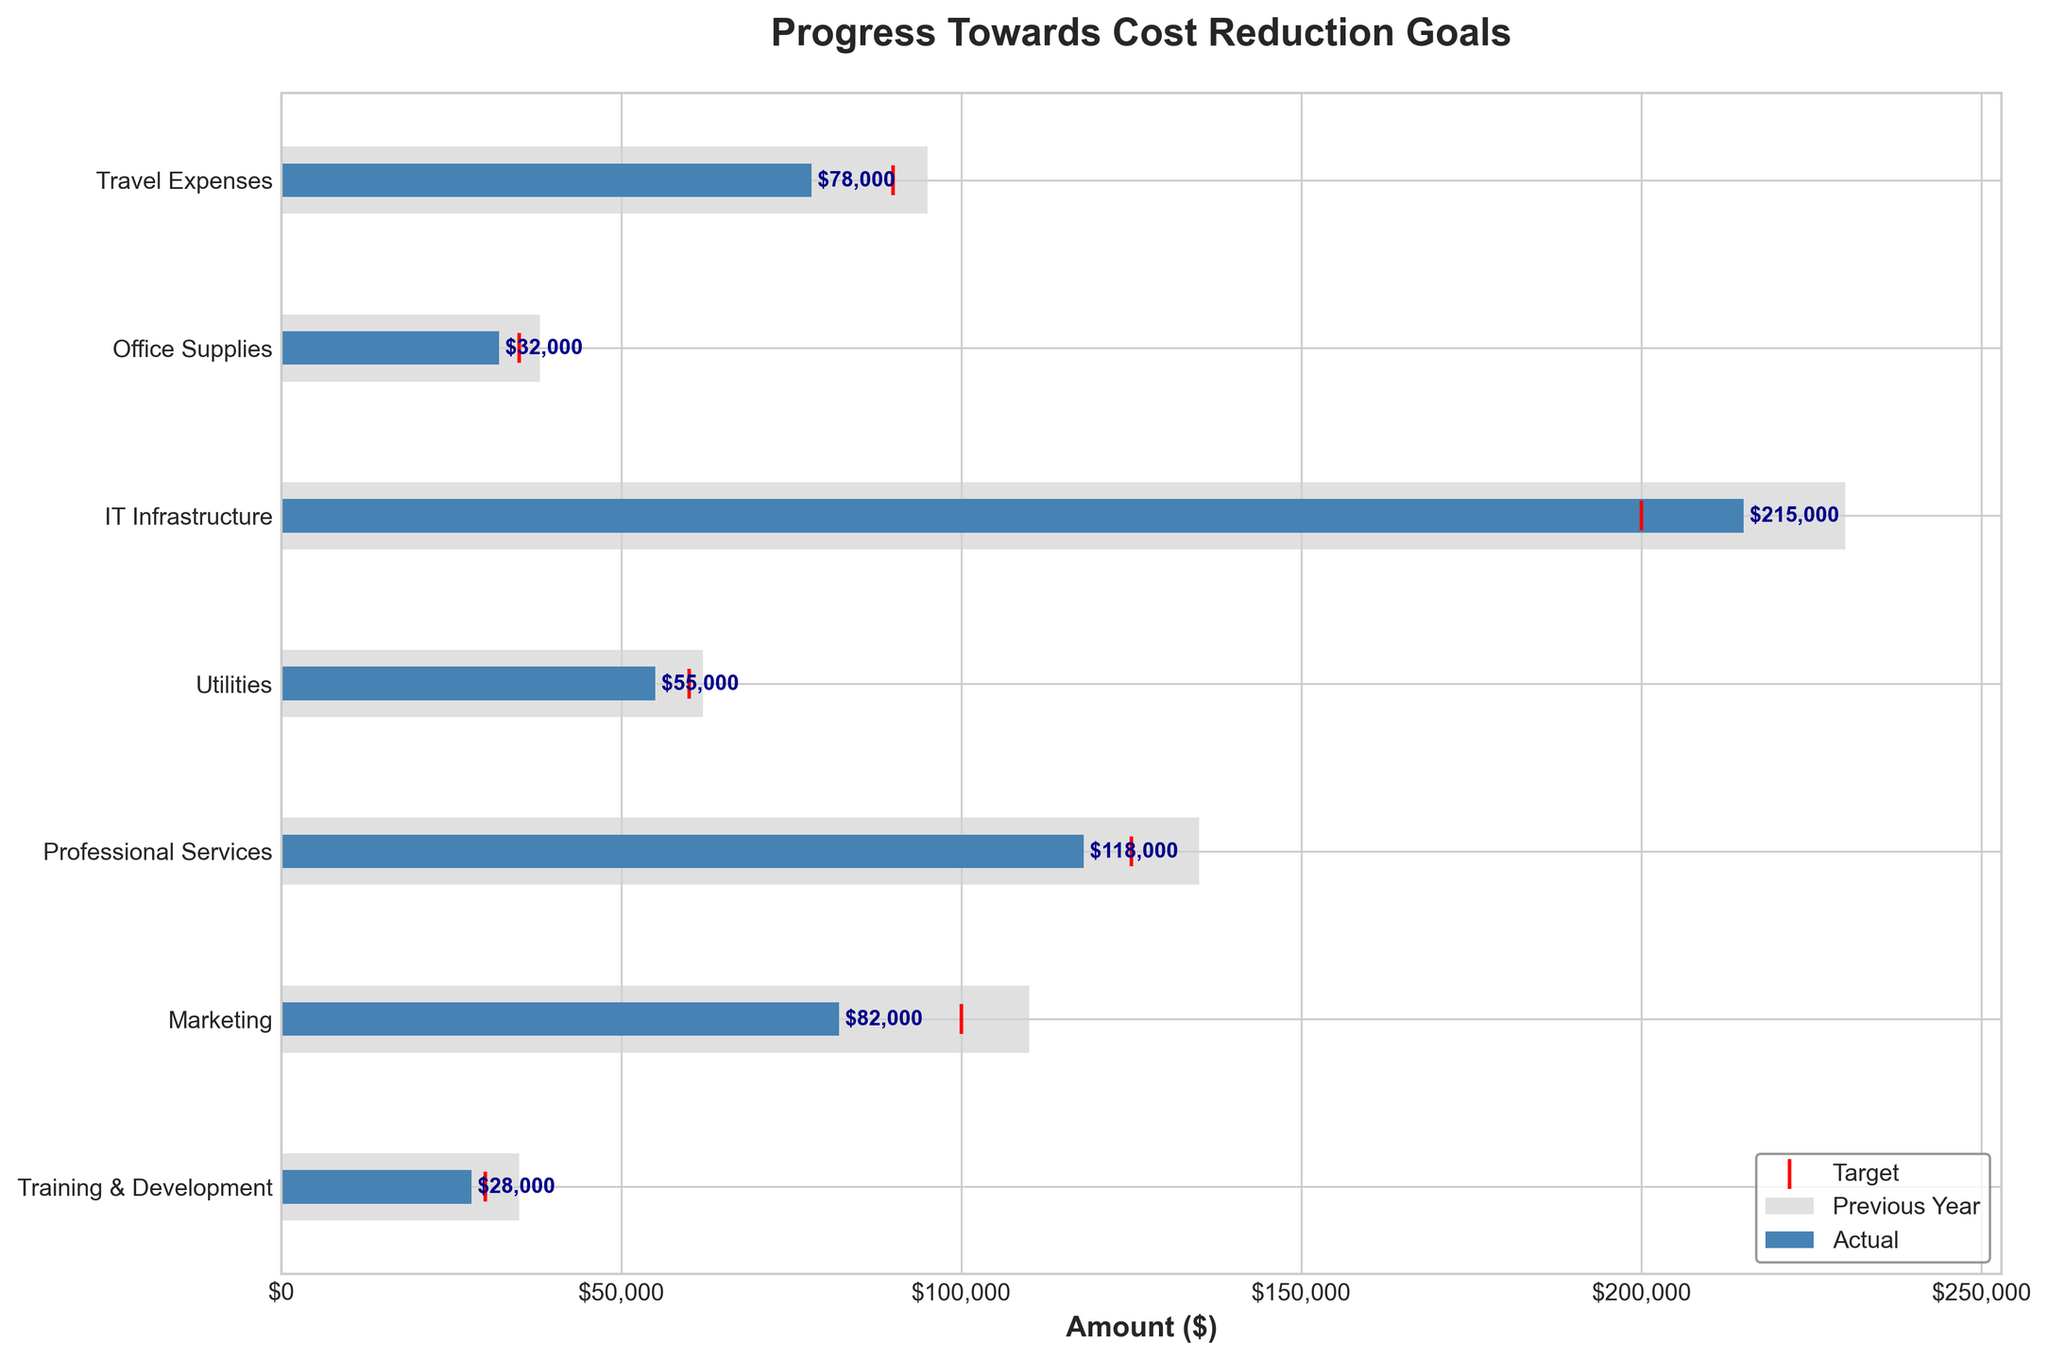How many categories of expenses are represented in the chart? Count the number of different categories listed on the y-axis.
Answer: 7 What are the actual expenses for Professional Services? Look at the 'Actual' bar for 'Professional Services' and identify the value labeled on the bar.
Answer: $118,000 By how much did the Marketing expenses decrease from the previous year to the actual? Subtract the 'Actual' value for Marketing from the 'Previous Year' value for Marketing: $110,000 - $82,000.
Answer: $28,000 What is the difference between the actual expenses and the target for IT Infrastructure? Subtract the 'Target' value from the 'Actual' value for IT Infrastructure: $215,000 - $200,000.
Answer: $15,000 Which category is closest to meeting its cost reduction target? Find the category with the smallest difference between 'Actual' and 'Target' values.
Answer: Office Supplies What is the average of the actual expenses across all categories? Add up all the actual expenses and divide by the number of categories: ($78,000 + $32,000 + $215,000 + $55,000 + $118,000 + $82,000 + $28,000) / 7.
Answer: $86,857 Compare the actual expenses for Travel Expenses to those for Office Supplies. Which is higher? Look at the 'Actual' values for Travel Expenses and Office Supplies and determine which is larger.
Answer: Travel Expenses What is the title of the chart? Read the title text at the top of the chart.
Answer: Progress Towards Cost Reduction Goals How does the target for Marketing compare to its previous year's expense? Compare the 'Target' marker to the 'Previous Year' bar for Marketing.
Answer: $10,000 less 